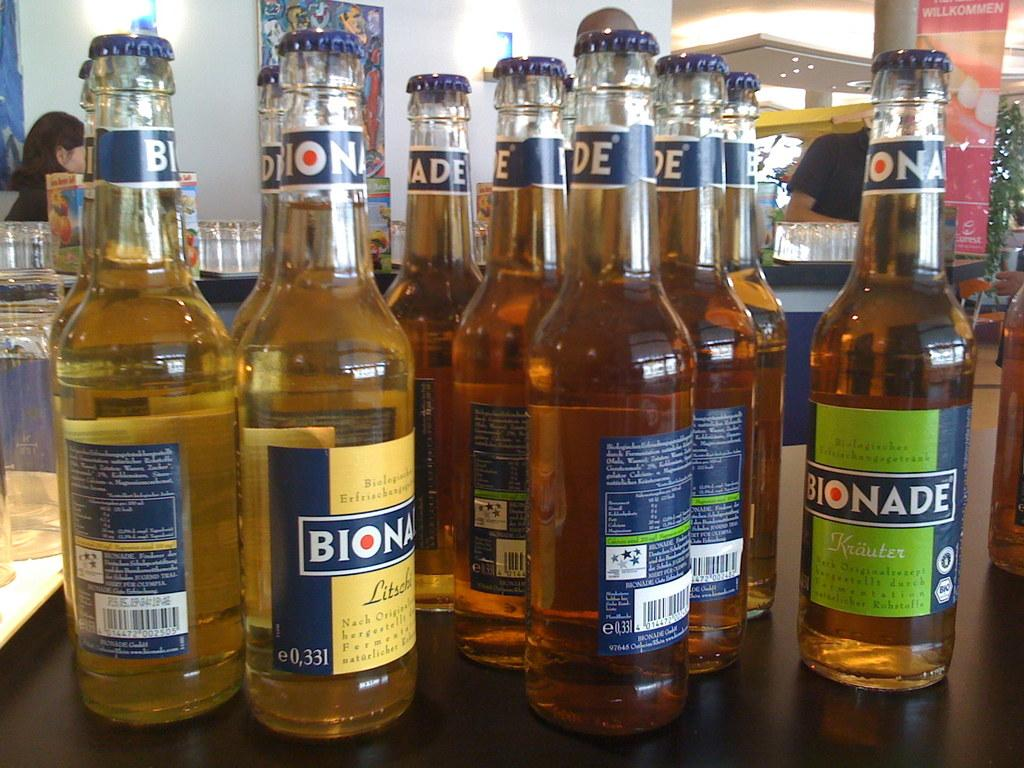<image>
Offer a succinct explanation of the picture presented. Several bottles of a beverage, made by Bionade, are grouped together. 